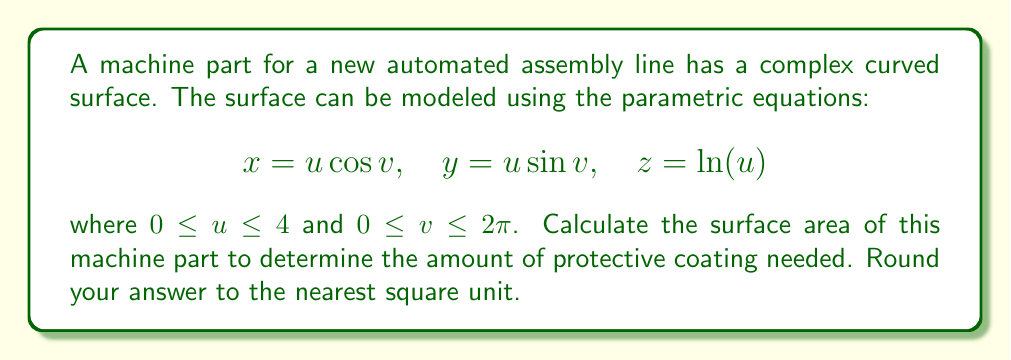Help me with this question. To find the surface area using parametric equations, we need to follow these steps:

1) First, we need to calculate the partial derivatives:
   $$\frac{\partial x}{\partial u} = \cos v, \quad \frac{\partial x}{\partial v} = -u \sin v$$
   $$\frac{\partial y}{\partial u} = \sin v, \quad \frac{\partial y}{\partial v} = u \cos v$$
   $$\frac{\partial z}{\partial u} = \frac{1}{u}, \quad \frac{\partial z}{\partial v} = 0$$

2) Now, we can calculate the cross product of these partial derivatives:
   $$\left|\frac{\partial \mathbf{r}}{\partial u} \times \frac{\partial \mathbf{r}}{\partial v}\right| = \left|\begin{vmatrix}
   \mathbf{i} & \mathbf{j} & \mathbf{k} \\
   \cos v & \sin v & \frac{1}{u} \\
   -u \sin v & u \cos v & 0
   \end{vmatrix}\right|$$

3) Evaluating this determinant:
   $$\left|\frac{\partial \mathbf{r}}{\partial u} \times \frac{\partial \mathbf{r}}{\partial v}\right| = \sqrt{u^2 \cos^2 v + u^2 \sin^2 v + \frac{u^2}{u^2}} = \sqrt{u^2 + 1}$$

4) The surface area is given by the double integral:
   $$A = \int_0^{2\pi} \int_0^4 \sqrt{u^2 + 1} \, du \, dv$$

5) Evaluating the inner integral:
   $$\int_0^4 \sqrt{u^2 + 1} \, du = \frac{1}{2}[u\sqrt{u^2+1} + \ln(u+\sqrt{u^2+1})]_0^4$$
   $$= \frac{1}{2}[4\sqrt{17} + \ln(4+\sqrt{17})]$$

6) The outer integral is just multiplication by $2\pi$ because the inner integral doesn't depend on $v$:
   $$A = \pi[4\sqrt{17} + \ln(4+\sqrt{17})] \approx 68.63$$

7) Rounding to the nearest square unit:
   $$A \approx 69 \text{ square units}$$
Answer: 69 square units 